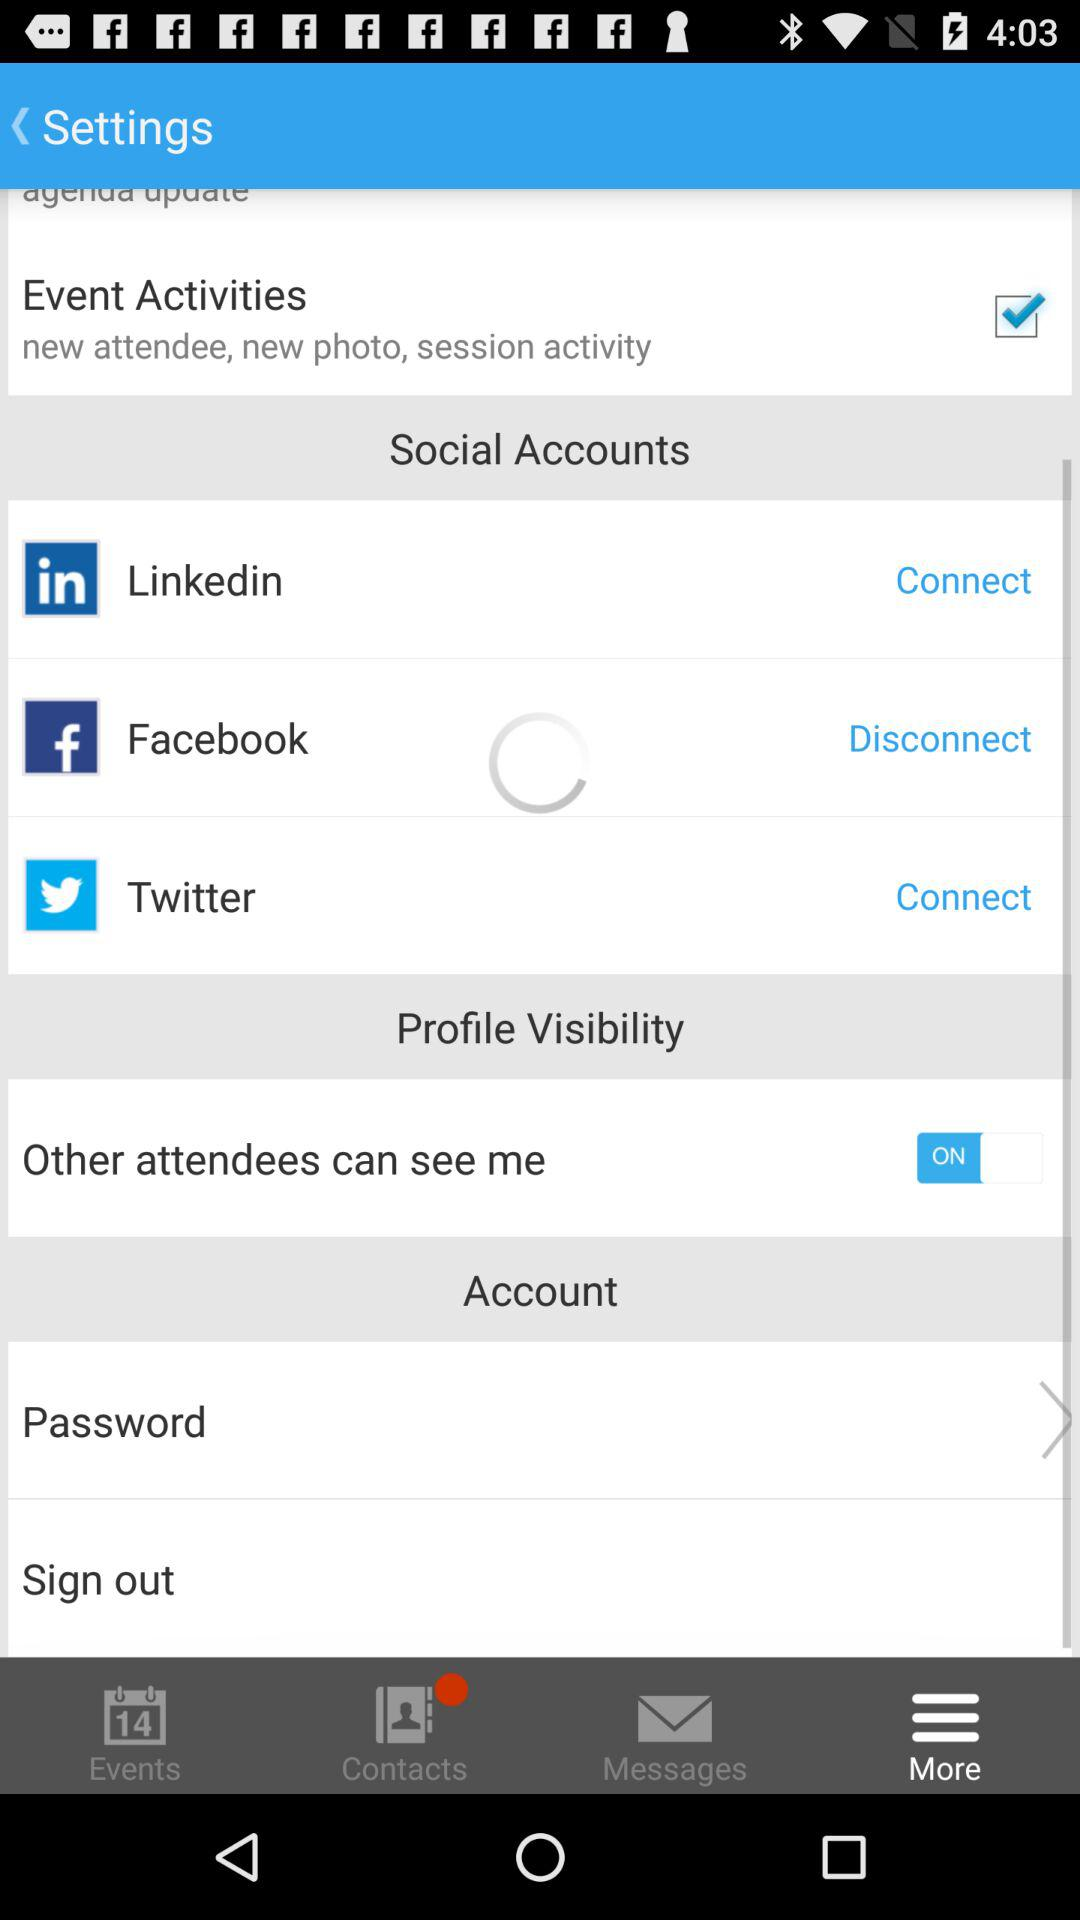What is the status of "Other attendees can see me"? "Other attendees can see me" is turned on. 